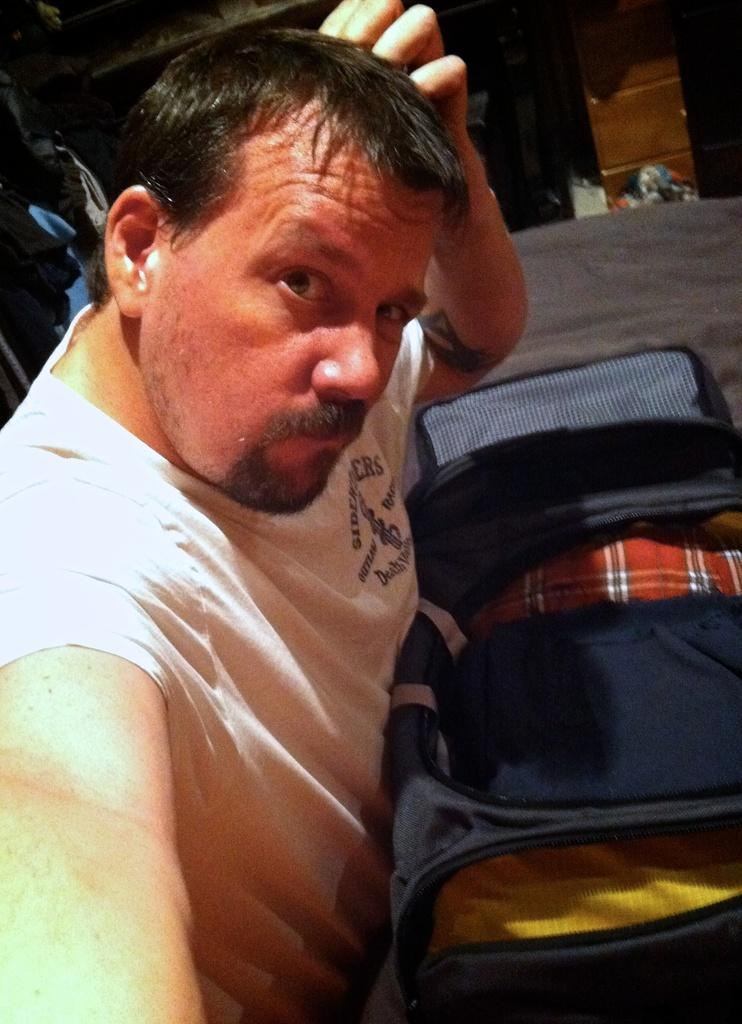Who or what is in the image? There is a person in the image. What is in front of the person? There is a bed in front of the person. What is on the bed? There is a luggage bag on the bed. What can be seen in the background of the image? There are objects visible in the background of the image. What type of letter is the person holding in the image? There is no letter present in the image; the person is not holding anything. 